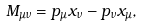<formula> <loc_0><loc_0><loc_500><loc_500>M _ { \mu \nu } = p _ { \mu } x _ { \nu } - p _ { \nu } x _ { \mu } ,</formula> 